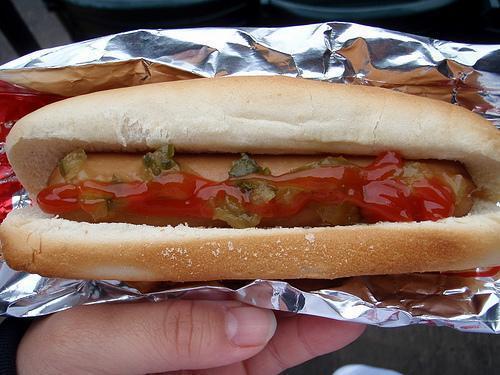Is the given caption "The person is touching the hot dog." fitting for the image?
Answer yes or no. No. 